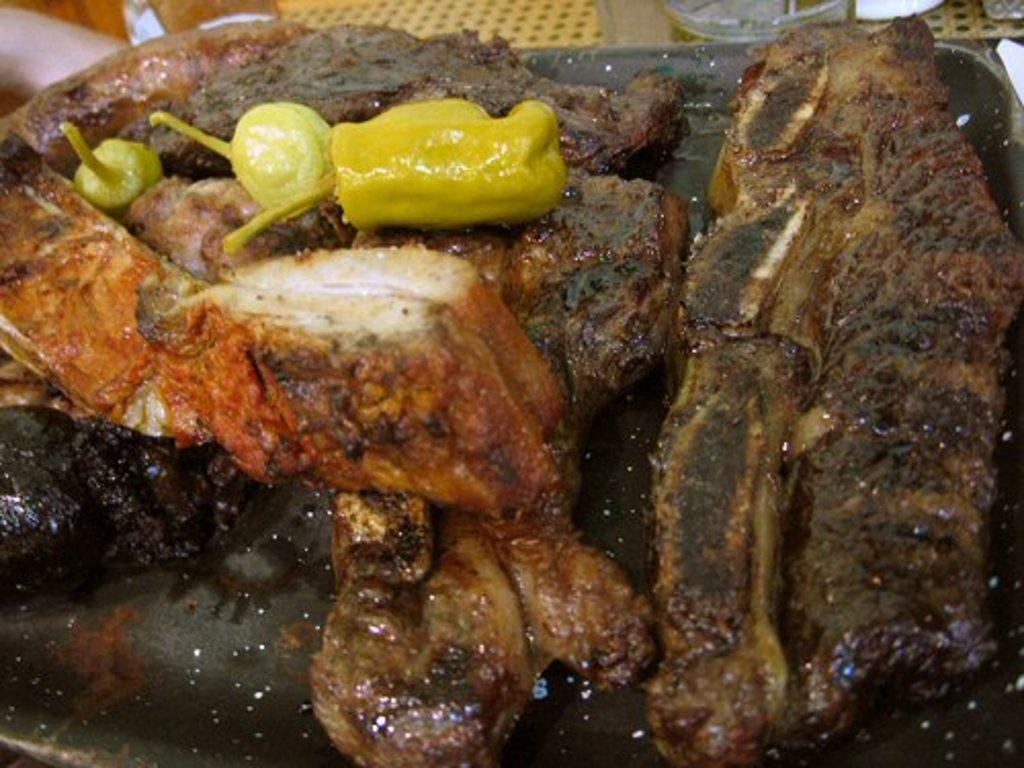What is present on the plate in the image? There are food items on the plate in the image. Can you describe the food items on the plate? Unfortunately, the specific food items cannot be determined from the provided facts. What can be seen behind the plate in the image? There are objects visible behind the plate in the image. How many jelly beans are on the giraffe's back in the image? There is no giraffe or jelly beans present in the image. What type of pump is visible in the image? There is no pump present in the image. 